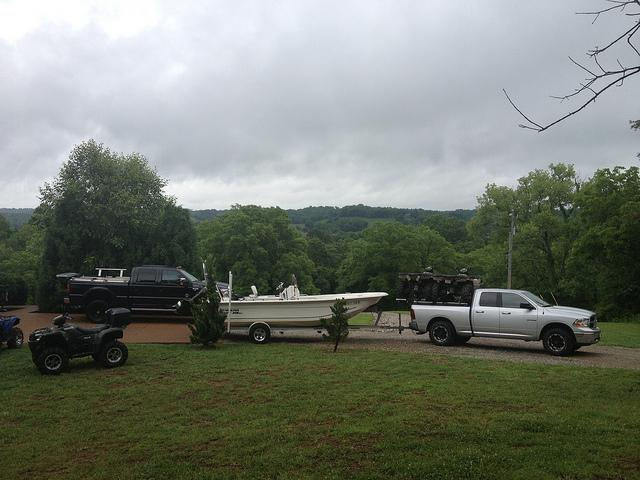What looks like it could happen any minute? rain 